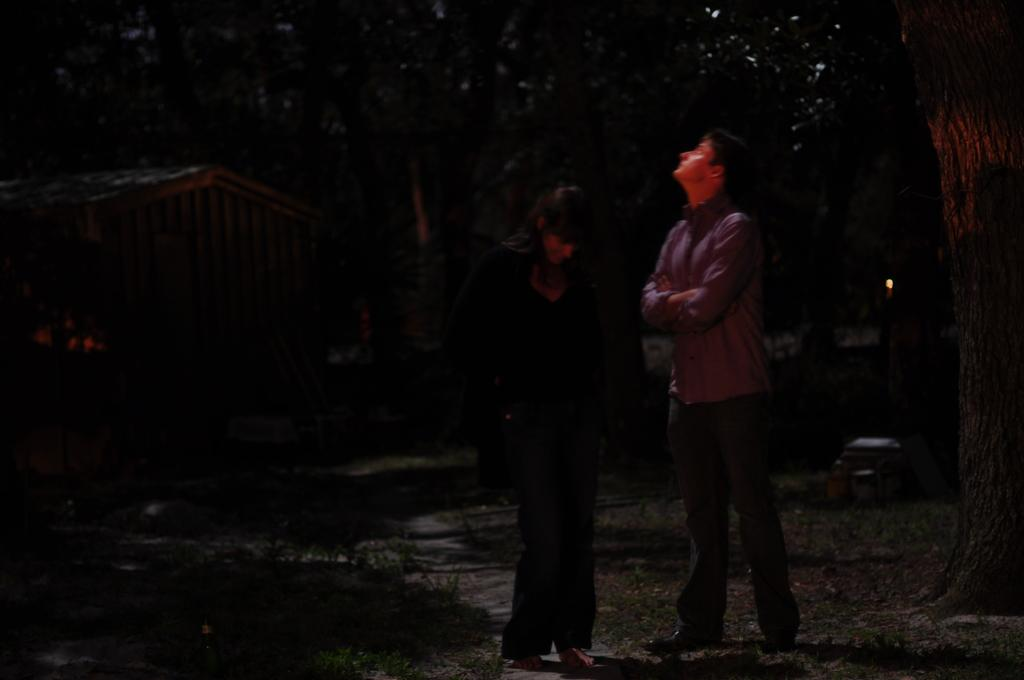What is the overall lighting condition in the image? The image is dark. How many people are present in the image? There are two people standing in the image. What type of natural elements can be seen in the image? There are trees visible in the image. What type of structure is present in the image? There is a wooden house in the image. What type of lock is used on the door of the wooden house in the image? There is no lock visible on the door of the wooden house in the image. How does the cork affect the growth of the trees in the image? There is no cork present in the image, and therefore it cannot affect the growth of the trees. 